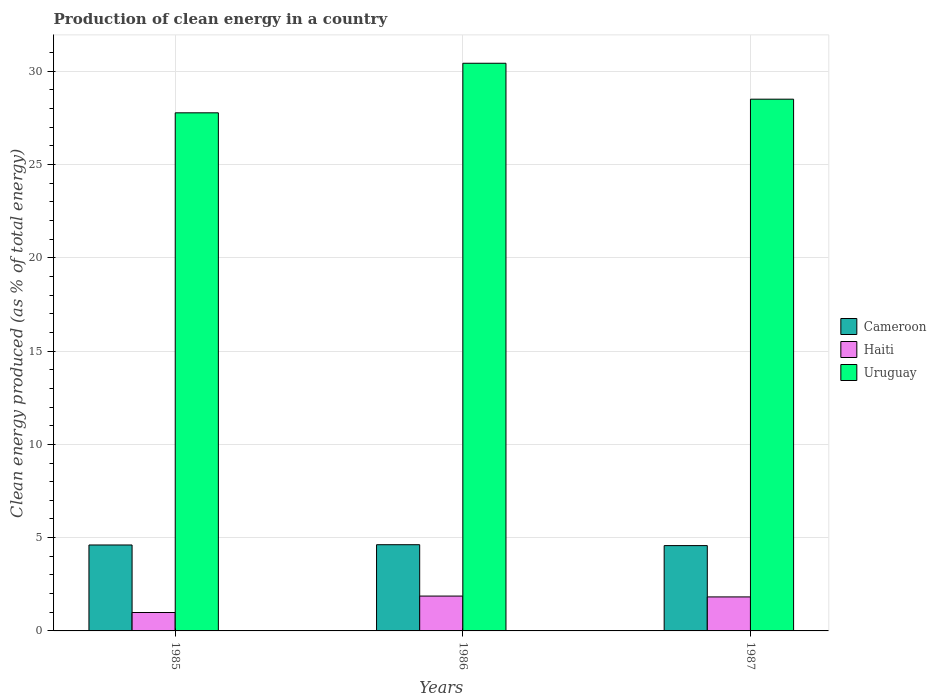Are the number of bars on each tick of the X-axis equal?
Offer a terse response. Yes. In how many cases, is the number of bars for a given year not equal to the number of legend labels?
Offer a very short reply. 0. What is the percentage of clean energy produced in Haiti in 1986?
Offer a terse response. 1.87. Across all years, what is the maximum percentage of clean energy produced in Cameroon?
Provide a succinct answer. 4.62. Across all years, what is the minimum percentage of clean energy produced in Haiti?
Ensure brevity in your answer.  0.99. What is the total percentage of clean energy produced in Uruguay in the graph?
Offer a terse response. 86.71. What is the difference between the percentage of clean energy produced in Uruguay in 1986 and that in 1987?
Your response must be concise. 1.93. What is the difference between the percentage of clean energy produced in Haiti in 1986 and the percentage of clean energy produced in Uruguay in 1987?
Keep it short and to the point. -26.64. What is the average percentage of clean energy produced in Uruguay per year?
Offer a terse response. 28.9. In the year 1986, what is the difference between the percentage of clean energy produced in Cameroon and percentage of clean energy produced in Uruguay?
Your answer should be compact. -25.81. What is the ratio of the percentage of clean energy produced in Uruguay in 1985 to that in 1986?
Ensure brevity in your answer.  0.91. What is the difference between the highest and the second highest percentage of clean energy produced in Haiti?
Make the answer very short. 0.05. What is the difference between the highest and the lowest percentage of clean energy produced in Uruguay?
Ensure brevity in your answer.  2.66. In how many years, is the percentage of clean energy produced in Haiti greater than the average percentage of clean energy produced in Haiti taken over all years?
Provide a succinct answer. 2. Is the sum of the percentage of clean energy produced in Haiti in 1985 and 1986 greater than the maximum percentage of clean energy produced in Cameroon across all years?
Your answer should be very brief. No. What does the 1st bar from the left in 1987 represents?
Ensure brevity in your answer.  Cameroon. What does the 1st bar from the right in 1987 represents?
Give a very brief answer. Uruguay. Is it the case that in every year, the sum of the percentage of clean energy produced in Haiti and percentage of clean energy produced in Uruguay is greater than the percentage of clean energy produced in Cameroon?
Give a very brief answer. Yes. Are all the bars in the graph horizontal?
Provide a short and direct response. No. Does the graph contain any zero values?
Your response must be concise. No. Does the graph contain grids?
Keep it short and to the point. Yes. What is the title of the graph?
Offer a very short reply. Production of clean energy in a country. Does "Israel" appear as one of the legend labels in the graph?
Your response must be concise. No. What is the label or title of the X-axis?
Provide a succinct answer. Years. What is the label or title of the Y-axis?
Your response must be concise. Clean energy produced (as % of total energy). What is the Clean energy produced (as % of total energy) of Cameroon in 1985?
Provide a succinct answer. 4.61. What is the Clean energy produced (as % of total energy) of Haiti in 1985?
Provide a succinct answer. 0.99. What is the Clean energy produced (as % of total energy) in Uruguay in 1985?
Keep it short and to the point. 27.77. What is the Clean energy produced (as % of total energy) of Cameroon in 1986?
Your answer should be very brief. 4.62. What is the Clean energy produced (as % of total energy) in Haiti in 1986?
Make the answer very short. 1.87. What is the Clean energy produced (as % of total energy) in Uruguay in 1986?
Your answer should be compact. 30.43. What is the Clean energy produced (as % of total energy) in Cameroon in 1987?
Your response must be concise. 4.57. What is the Clean energy produced (as % of total energy) in Haiti in 1987?
Your answer should be very brief. 1.82. What is the Clean energy produced (as % of total energy) in Uruguay in 1987?
Offer a very short reply. 28.51. Across all years, what is the maximum Clean energy produced (as % of total energy) of Cameroon?
Ensure brevity in your answer.  4.62. Across all years, what is the maximum Clean energy produced (as % of total energy) of Haiti?
Provide a short and direct response. 1.87. Across all years, what is the maximum Clean energy produced (as % of total energy) of Uruguay?
Offer a terse response. 30.43. Across all years, what is the minimum Clean energy produced (as % of total energy) in Cameroon?
Make the answer very short. 4.57. Across all years, what is the minimum Clean energy produced (as % of total energy) in Haiti?
Keep it short and to the point. 0.99. Across all years, what is the minimum Clean energy produced (as % of total energy) of Uruguay?
Offer a terse response. 27.77. What is the total Clean energy produced (as % of total energy) of Cameroon in the graph?
Give a very brief answer. 13.8. What is the total Clean energy produced (as % of total energy) in Haiti in the graph?
Make the answer very short. 4.68. What is the total Clean energy produced (as % of total energy) of Uruguay in the graph?
Provide a succinct answer. 86.71. What is the difference between the Clean energy produced (as % of total energy) in Cameroon in 1985 and that in 1986?
Ensure brevity in your answer.  -0.01. What is the difference between the Clean energy produced (as % of total energy) of Haiti in 1985 and that in 1986?
Offer a very short reply. -0.88. What is the difference between the Clean energy produced (as % of total energy) of Uruguay in 1985 and that in 1986?
Provide a short and direct response. -2.66. What is the difference between the Clean energy produced (as % of total energy) of Cameroon in 1985 and that in 1987?
Offer a terse response. 0.03. What is the difference between the Clean energy produced (as % of total energy) in Haiti in 1985 and that in 1987?
Make the answer very short. -0.84. What is the difference between the Clean energy produced (as % of total energy) of Uruguay in 1985 and that in 1987?
Offer a very short reply. -0.73. What is the difference between the Clean energy produced (as % of total energy) of Cameroon in 1986 and that in 1987?
Give a very brief answer. 0.05. What is the difference between the Clean energy produced (as % of total energy) of Haiti in 1986 and that in 1987?
Offer a very short reply. 0.05. What is the difference between the Clean energy produced (as % of total energy) in Uruguay in 1986 and that in 1987?
Offer a terse response. 1.93. What is the difference between the Clean energy produced (as % of total energy) in Cameroon in 1985 and the Clean energy produced (as % of total energy) in Haiti in 1986?
Keep it short and to the point. 2.74. What is the difference between the Clean energy produced (as % of total energy) of Cameroon in 1985 and the Clean energy produced (as % of total energy) of Uruguay in 1986?
Offer a terse response. -25.82. What is the difference between the Clean energy produced (as % of total energy) in Haiti in 1985 and the Clean energy produced (as % of total energy) in Uruguay in 1986?
Make the answer very short. -29.44. What is the difference between the Clean energy produced (as % of total energy) in Cameroon in 1985 and the Clean energy produced (as % of total energy) in Haiti in 1987?
Offer a terse response. 2.78. What is the difference between the Clean energy produced (as % of total energy) in Cameroon in 1985 and the Clean energy produced (as % of total energy) in Uruguay in 1987?
Make the answer very short. -23.9. What is the difference between the Clean energy produced (as % of total energy) in Haiti in 1985 and the Clean energy produced (as % of total energy) in Uruguay in 1987?
Your response must be concise. -27.52. What is the difference between the Clean energy produced (as % of total energy) in Cameroon in 1986 and the Clean energy produced (as % of total energy) in Haiti in 1987?
Your answer should be very brief. 2.8. What is the difference between the Clean energy produced (as % of total energy) of Cameroon in 1986 and the Clean energy produced (as % of total energy) of Uruguay in 1987?
Provide a short and direct response. -23.88. What is the difference between the Clean energy produced (as % of total energy) of Haiti in 1986 and the Clean energy produced (as % of total energy) of Uruguay in 1987?
Provide a short and direct response. -26.64. What is the average Clean energy produced (as % of total energy) of Cameroon per year?
Provide a short and direct response. 4.6. What is the average Clean energy produced (as % of total energy) of Haiti per year?
Offer a very short reply. 1.56. What is the average Clean energy produced (as % of total energy) of Uruguay per year?
Keep it short and to the point. 28.9. In the year 1985, what is the difference between the Clean energy produced (as % of total energy) of Cameroon and Clean energy produced (as % of total energy) of Haiti?
Your answer should be very brief. 3.62. In the year 1985, what is the difference between the Clean energy produced (as % of total energy) of Cameroon and Clean energy produced (as % of total energy) of Uruguay?
Offer a terse response. -23.17. In the year 1985, what is the difference between the Clean energy produced (as % of total energy) of Haiti and Clean energy produced (as % of total energy) of Uruguay?
Provide a succinct answer. -26.79. In the year 1986, what is the difference between the Clean energy produced (as % of total energy) of Cameroon and Clean energy produced (as % of total energy) of Haiti?
Your answer should be compact. 2.75. In the year 1986, what is the difference between the Clean energy produced (as % of total energy) in Cameroon and Clean energy produced (as % of total energy) in Uruguay?
Make the answer very short. -25.81. In the year 1986, what is the difference between the Clean energy produced (as % of total energy) in Haiti and Clean energy produced (as % of total energy) in Uruguay?
Your answer should be compact. -28.56. In the year 1987, what is the difference between the Clean energy produced (as % of total energy) in Cameroon and Clean energy produced (as % of total energy) in Haiti?
Give a very brief answer. 2.75. In the year 1987, what is the difference between the Clean energy produced (as % of total energy) of Cameroon and Clean energy produced (as % of total energy) of Uruguay?
Your response must be concise. -23.93. In the year 1987, what is the difference between the Clean energy produced (as % of total energy) of Haiti and Clean energy produced (as % of total energy) of Uruguay?
Provide a succinct answer. -26.68. What is the ratio of the Clean energy produced (as % of total energy) of Haiti in 1985 to that in 1986?
Keep it short and to the point. 0.53. What is the ratio of the Clean energy produced (as % of total energy) in Uruguay in 1985 to that in 1986?
Make the answer very short. 0.91. What is the ratio of the Clean energy produced (as % of total energy) of Haiti in 1985 to that in 1987?
Make the answer very short. 0.54. What is the ratio of the Clean energy produced (as % of total energy) in Uruguay in 1985 to that in 1987?
Keep it short and to the point. 0.97. What is the ratio of the Clean energy produced (as % of total energy) in Cameroon in 1986 to that in 1987?
Provide a short and direct response. 1.01. What is the ratio of the Clean energy produced (as % of total energy) in Haiti in 1986 to that in 1987?
Your answer should be compact. 1.02. What is the ratio of the Clean energy produced (as % of total energy) in Uruguay in 1986 to that in 1987?
Your answer should be compact. 1.07. What is the difference between the highest and the second highest Clean energy produced (as % of total energy) in Cameroon?
Offer a very short reply. 0.01. What is the difference between the highest and the second highest Clean energy produced (as % of total energy) in Haiti?
Ensure brevity in your answer.  0.05. What is the difference between the highest and the second highest Clean energy produced (as % of total energy) in Uruguay?
Ensure brevity in your answer.  1.93. What is the difference between the highest and the lowest Clean energy produced (as % of total energy) of Cameroon?
Offer a terse response. 0.05. What is the difference between the highest and the lowest Clean energy produced (as % of total energy) in Haiti?
Your answer should be compact. 0.88. What is the difference between the highest and the lowest Clean energy produced (as % of total energy) of Uruguay?
Offer a terse response. 2.66. 